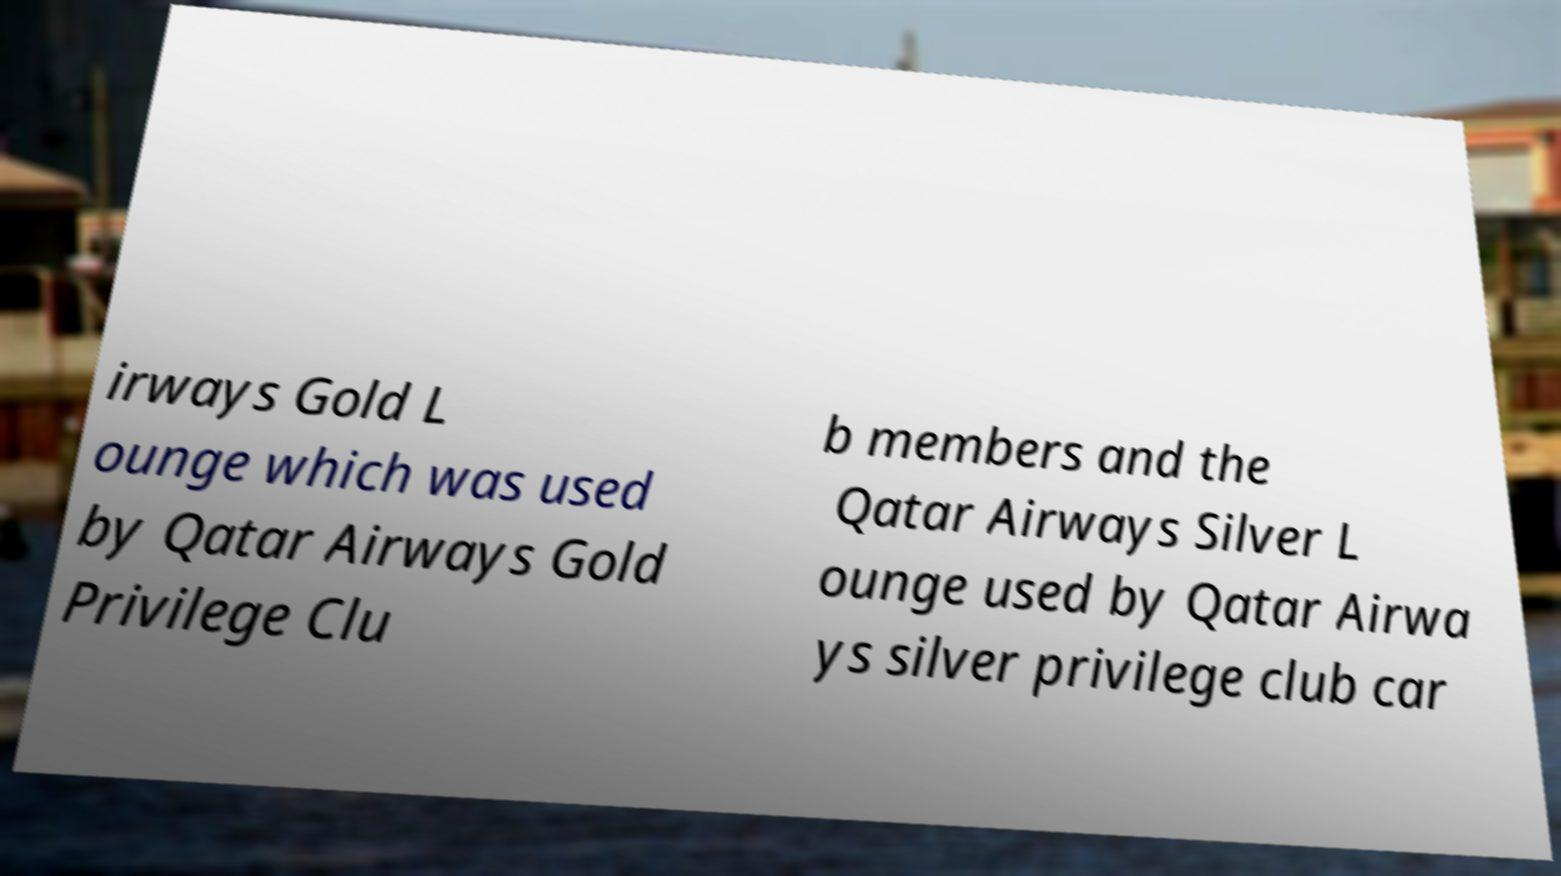Please read and relay the text visible in this image. What does it say? irways Gold L ounge which was used by Qatar Airways Gold Privilege Clu b members and the Qatar Airways Silver L ounge used by Qatar Airwa ys silver privilege club car 